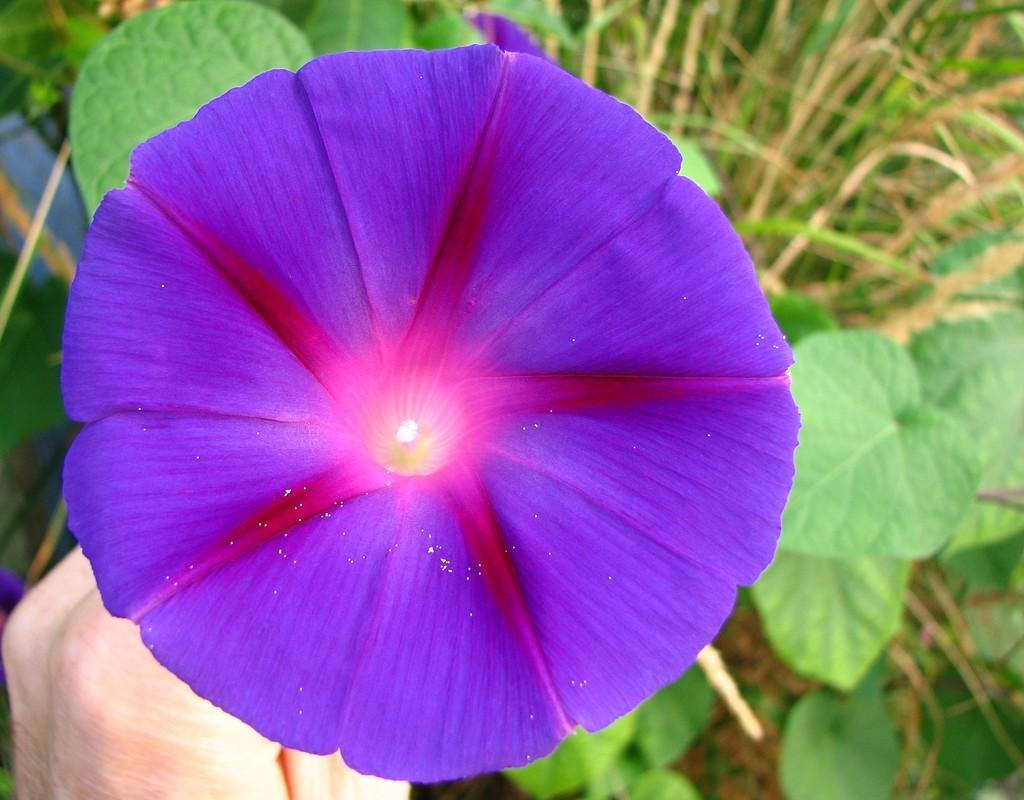What colors are the flowers in the image? The flowers in the image are pink and purple. Where are the flowers located? The flowers are on a plant. What type of vegetation is visible in the image besides the flowers? There is grass visible in the image. Whose hand is present in the image? A human hand is present in the image. What type of flower is the mother holding in the image? There is no mother or flower being held in the image; it only features pink and purple flowers on a plant, grass, and a human hand. 